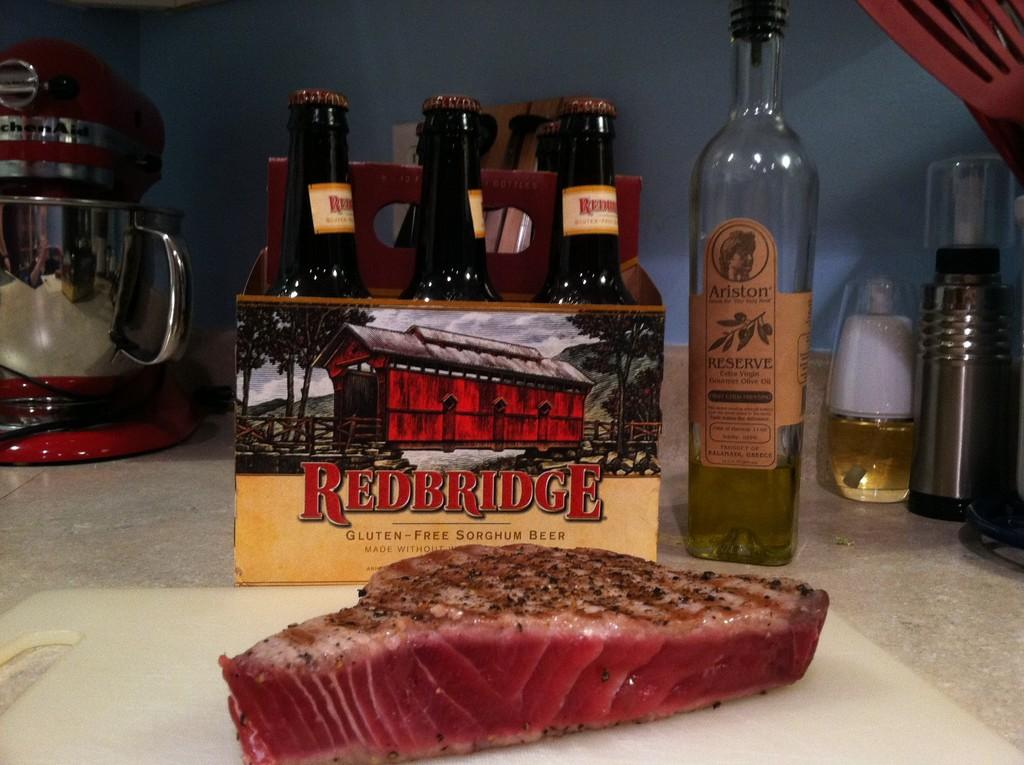Provide a one-sentence caption for the provided image. A six pack of Redbridge beer and a bottle of Arison Reserve sit on a countertop behind a cut of meat. 